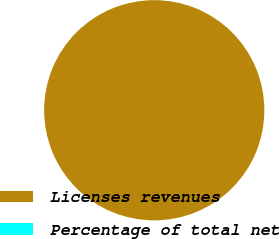Convert chart. <chart><loc_0><loc_0><loc_500><loc_500><pie_chart><fcel>Licenses revenues<fcel>Percentage of total net<nl><fcel>100.0%<fcel>0.0%<nl></chart> 